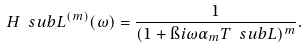<formula> <loc_0><loc_0><loc_500><loc_500>H \ s u b { L } ^ { ( m ) } ( \omega ) = \frac { 1 } { ( 1 + \i i \omega \alpha _ { m } T \ s u b { L } ) ^ { m } } .</formula> 